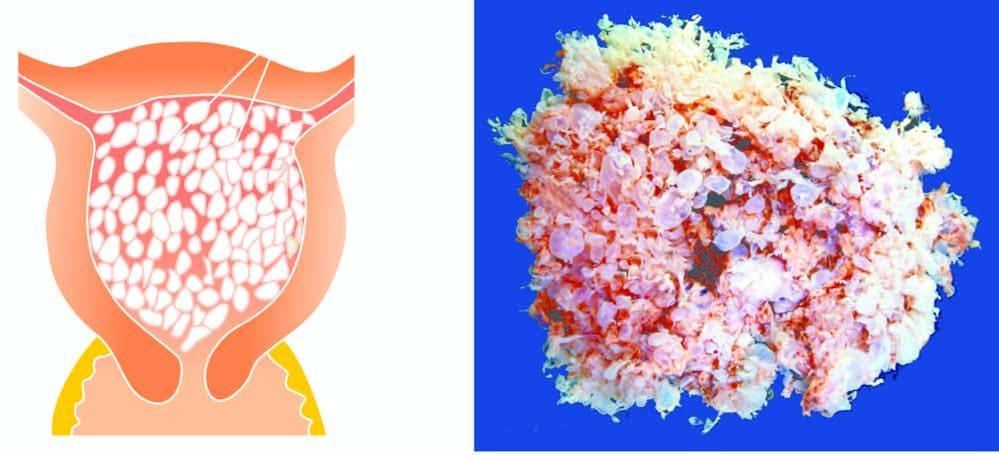what shows numerous, variable-sized, grape-like translucent vesicles containing clear fluid?
Answer the question using a single word or phrase. Specimen 